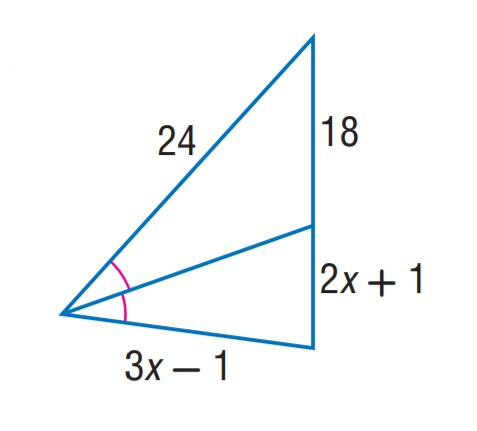Question: Find x.
Choices:
A. 5
B. 6
C. 7
D. 8
Answer with the letter. Answer: C 